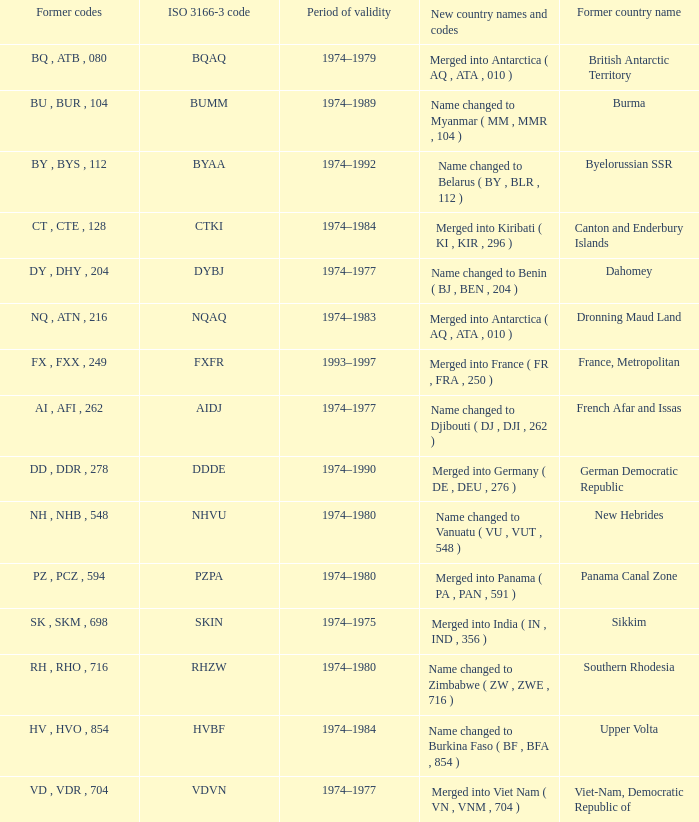What is the total duration of validity for upper volta? 1.0. 